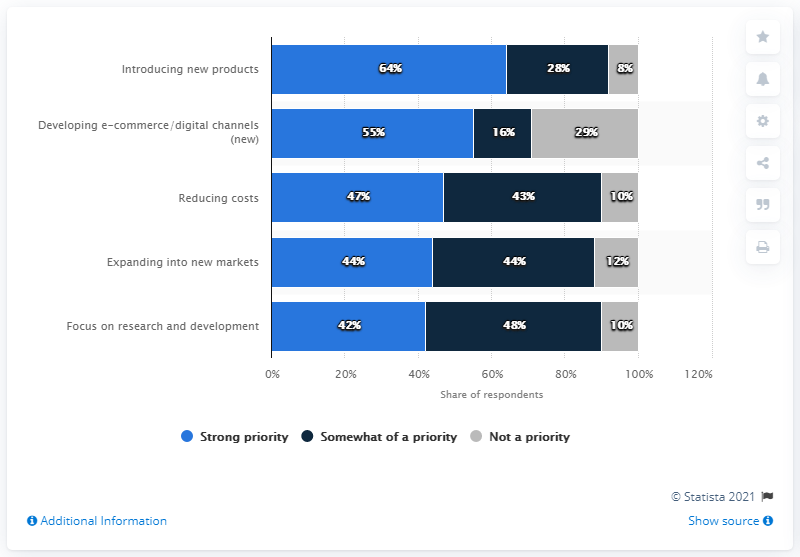Give some essential details in this illustration. The maximum value of "strong priority" is different from the minimum value of "not a priority" by 56. The majority of businesses prioritize reducing costs as a strong priority for their strategies over the next 12 months, with 47% indicating that this is their top priority. 